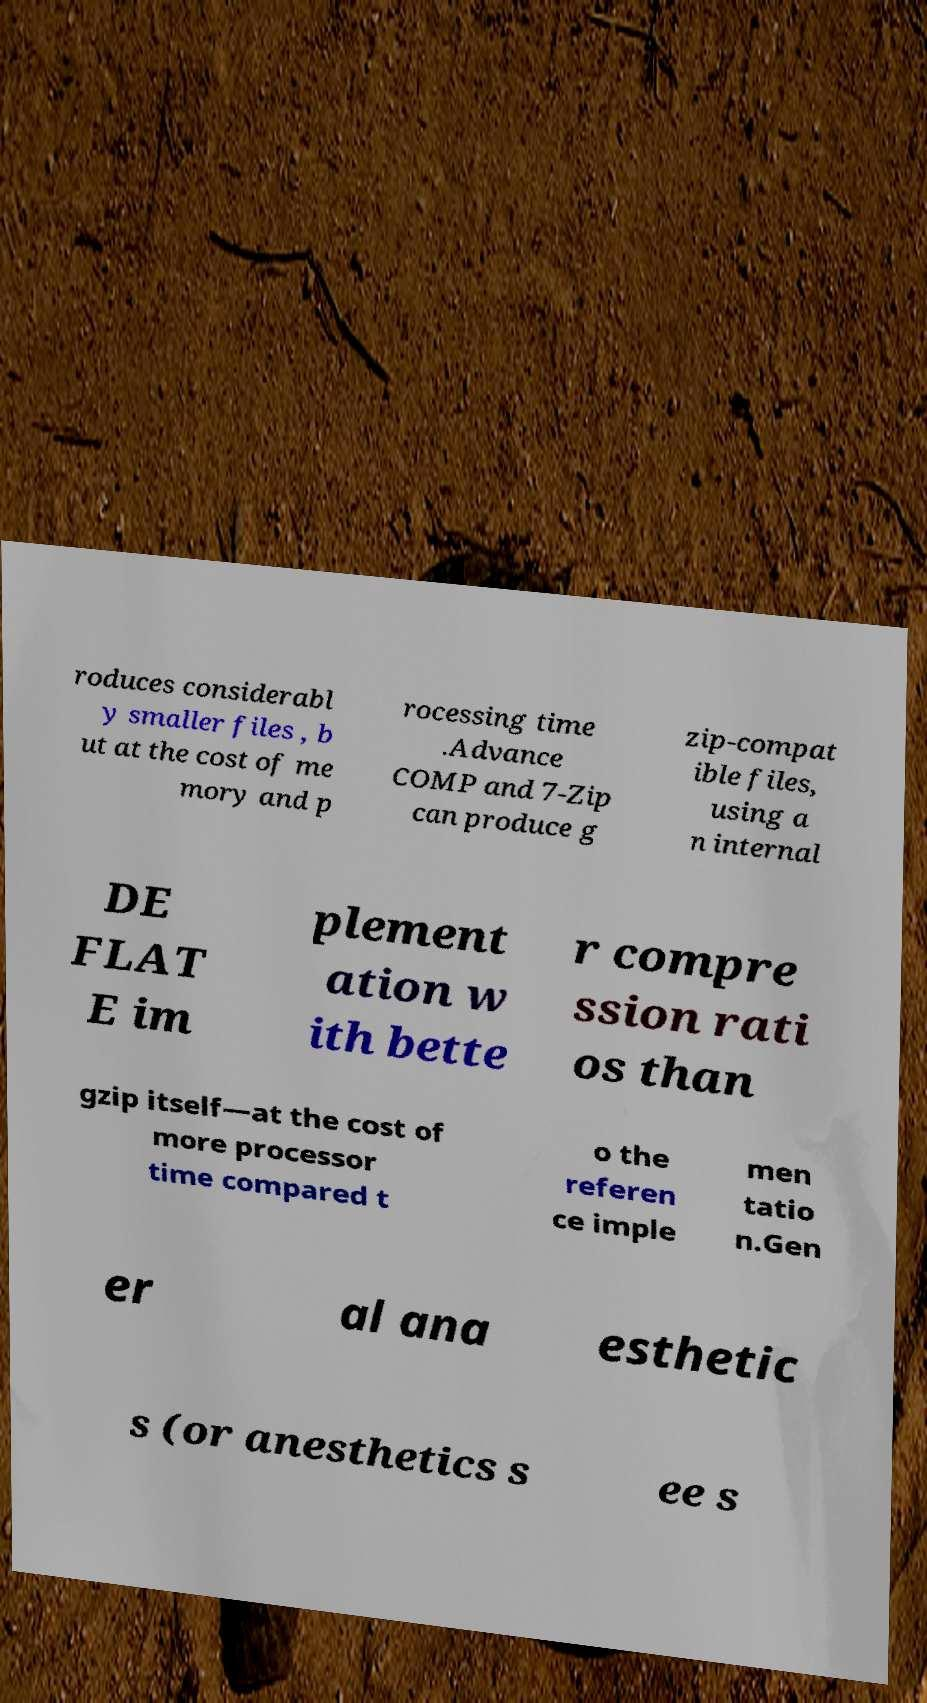I need the written content from this picture converted into text. Can you do that? roduces considerabl y smaller files , b ut at the cost of me mory and p rocessing time .Advance COMP and 7-Zip can produce g zip-compat ible files, using a n internal DE FLAT E im plement ation w ith bette r compre ssion rati os than gzip itself—at the cost of more processor time compared t o the referen ce imple men tatio n.Gen er al ana esthetic s (or anesthetics s ee s 